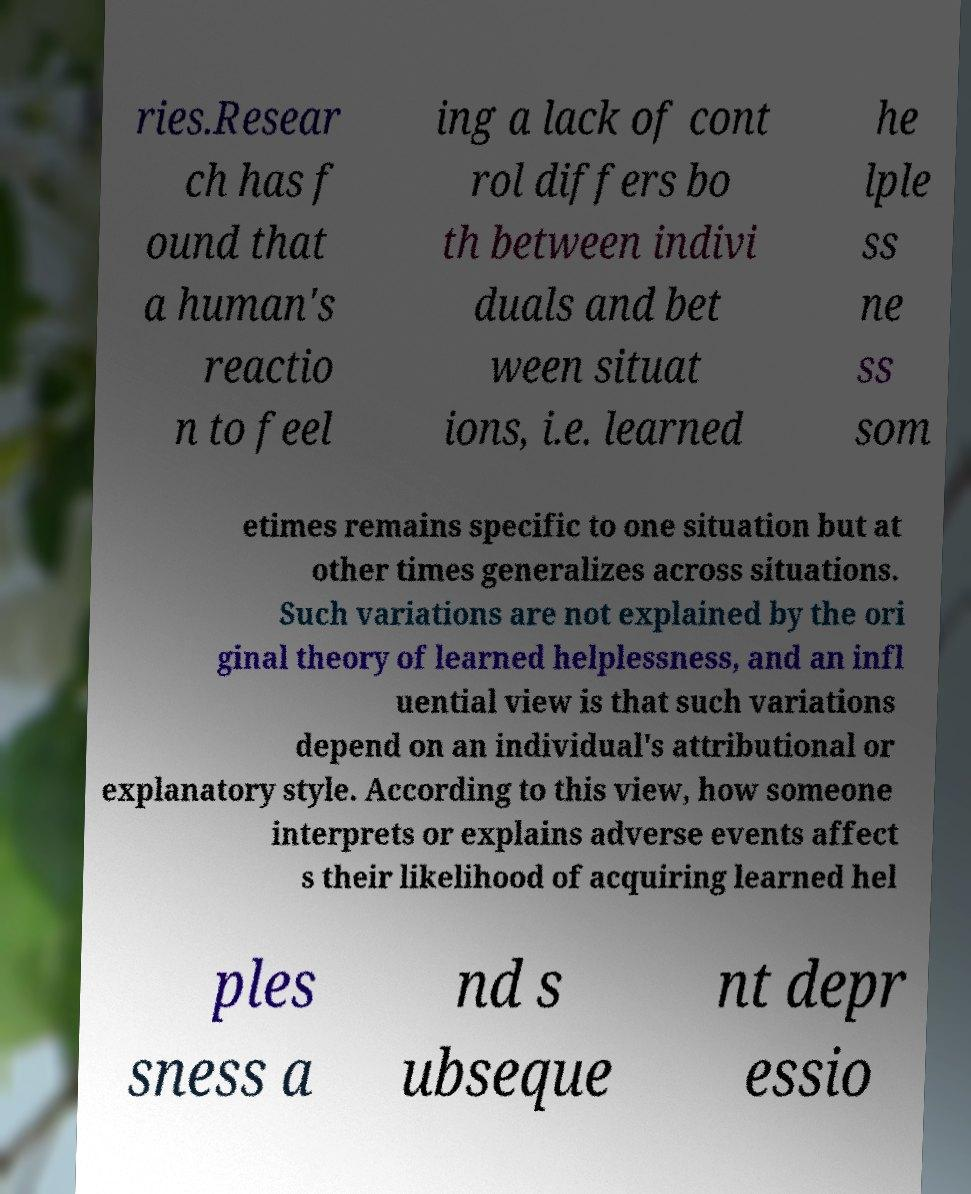There's text embedded in this image that I need extracted. Can you transcribe it verbatim? ries.Resear ch has f ound that a human's reactio n to feel ing a lack of cont rol differs bo th between indivi duals and bet ween situat ions, i.e. learned he lple ss ne ss som etimes remains specific to one situation but at other times generalizes across situations. Such variations are not explained by the ori ginal theory of learned helplessness, and an infl uential view is that such variations depend on an individual's attributional or explanatory style. According to this view, how someone interprets or explains adverse events affect s their likelihood of acquiring learned hel ples sness a nd s ubseque nt depr essio 